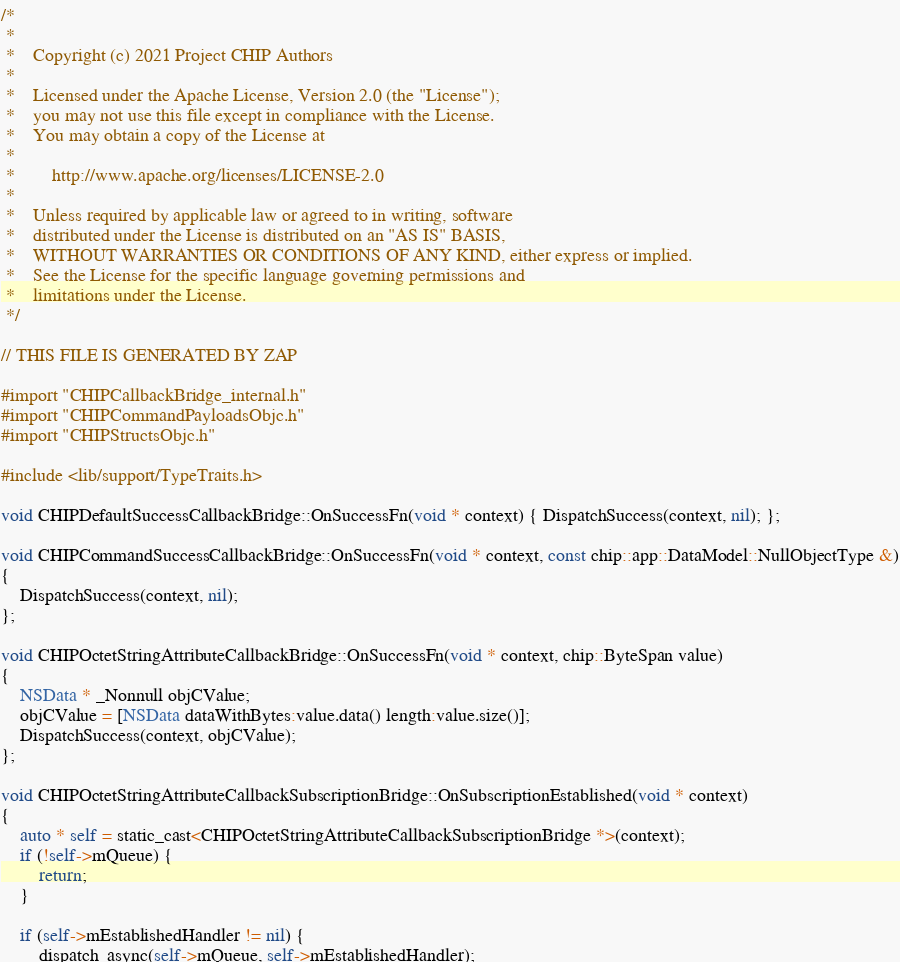Convert code to text. <code><loc_0><loc_0><loc_500><loc_500><_ObjectiveC_>/*
 *
 *    Copyright (c) 2021 Project CHIP Authors
 *
 *    Licensed under the Apache License, Version 2.0 (the "License");
 *    you may not use this file except in compliance with the License.
 *    You may obtain a copy of the License at
 *
 *        http://www.apache.org/licenses/LICENSE-2.0
 *
 *    Unless required by applicable law or agreed to in writing, software
 *    distributed under the License is distributed on an "AS IS" BASIS,
 *    WITHOUT WARRANTIES OR CONDITIONS OF ANY KIND, either express or implied.
 *    See the License for the specific language governing permissions and
 *    limitations under the License.
 */

// THIS FILE IS GENERATED BY ZAP

#import "CHIPCallbackBridge_internal.h"
#import "CHIPCommandPayloadsObjc.h"
#import "CHIPStructsObjc.h"

#include <lib/support/TypeTraits.h>

void CHIPDefaultSuccessCallbackBridge::OnSuccessFn(void * context) { DispatchSuccess(context, nil); };

void CHIPCommandSuccessCallbackBridge::OnSuccessFn(void * context, const chip::app::DataModel::NullObjectType &)
{
    DispatchSuccess(context, nil);
};

void CHIPOctetStringAttributeCallbackBridge::OnSuccessFn(void * context, chip::ByteSpan value)
{
    NSData * _Nonnull objCValue;
    objCValue = [NSData dataWithBytes:value.data() length:value.size()];
    DispatchSuccess(context, objCValue);
};

void CHIPOctetStringAttributeCallbackSubscriptionBridge::OnSubscriptionEstablished(void * context)
{
    auto * self = static_cast<CHIPOctetStringAttributeCallbackSubscriptionBridge *>(context);
    if (!self->mQueue) {
        return;
    }

    if (self->mEstablishedHandler != nil) {
        dispatch_async(self->mQueue, self->mEstablishedHandler);</code> 